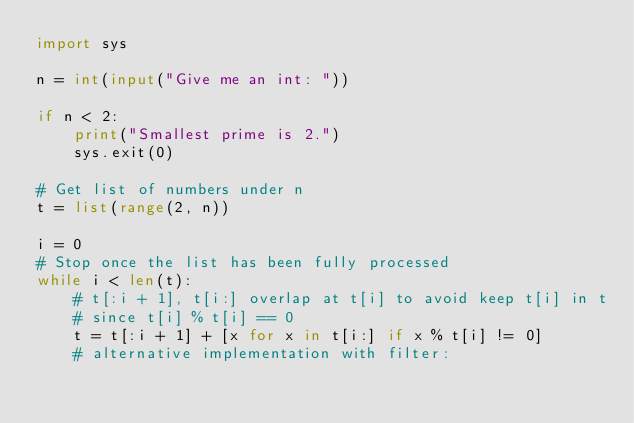<code> <loc_0><loc_0><loc_500><loc_500><_Python_>import sys

n = int(input("Give me an int: "))

if n < 2:
    print("Smallest prime is 2.")
    sys.exit(0)

# Get list of numbers under n
t = list(range(2, n))

i = 0
# Stop once the list has been fully processed
while i < len(t):
    # t[:i + 1], t[i:] overlap at t[i] to avoid keep t[i] in t
    # since t[i] % t[i] == 0
    t = t[:i + 1] + [x for x in t[i:] if x % t[i] != 0]
    # alternative implementation with filter:</code> 